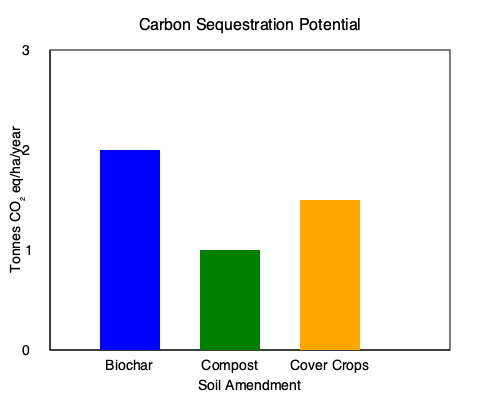Based on the graph showing the carbon sequestration potential of different soil amendments, which amendment has the highest potential for sequestering carbon in the soil? Calculate the difference in carbon sequestration potential between the most effective and least effective amendments shown. To answer this question, we need to analyze the bar graph and compare the heights of the bars representing each soil amendment:

1. Biochar: The bar reaches approximately 2.5 tonnes CO₂ eq/ha/year
2. Compost: The bar reaches approximately 1 tonne CO₂ eq/ha/year
3. Cover Crops: The bar reaches approximately 1.5 tonnes CO₂ eq/ha/year

Step 1: Identify the amendment with the highest potential
Biochar has the tallest bar, reaching about 2.5 tonnes CO₂ eq/ha/year, making it the amendment with the highest carbon sequestration potential.

Step 2: Identify the amendment with the lowest potential
Compost has the shortest bar, reaching about 1 tonne CO₂ eq/ha/year, making it the amendment with the lowest carbon sequestration potential.

Step 3: Calculate the difference between the highest and lowest potentials
Difference = Highest potential - Lowest potential
Difference = 2.5 - 1 = 1.5 tonnes CO₂ eq/ha/year

Therefore, biochar has the highest carbon sequestration potential, and the difference between the most effective (biochar) and least effective (compost) amendments is 1.5 tonnes CO₂ eq/ha/year.
Answer: Biochar; 1.5 tonnes CO₂ eq/ha/year 